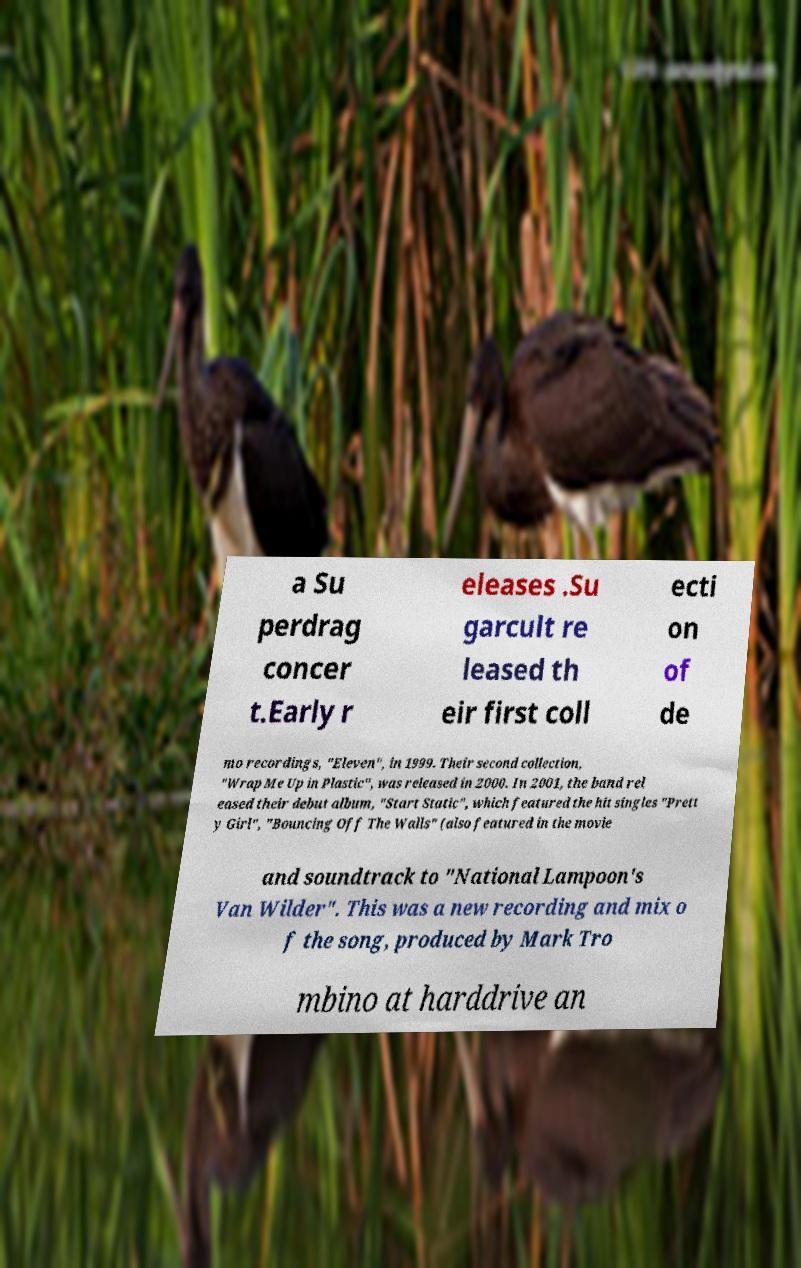There's text embedded in this image that I need extracted. Can you transcribe it verbatim? a Su perdrag concer t.Early r eleases .Su garcult re leased th eir first coll ecti on of de mo recordings, "Eleven", in 1999. Their second collection, "Wrap Me Up in Plastic", was released in 2000. In 2001, the band rel eased their debut album, "Start Static", which featured the hit singles "Prett y Girl", "Bouncing Off The Walls" (also featured in the movie and soundtrack to "National Lampoon's Van Wilder". This was a new recording and mix o f the song, produced by Mark Tro mbino at harddrive an 